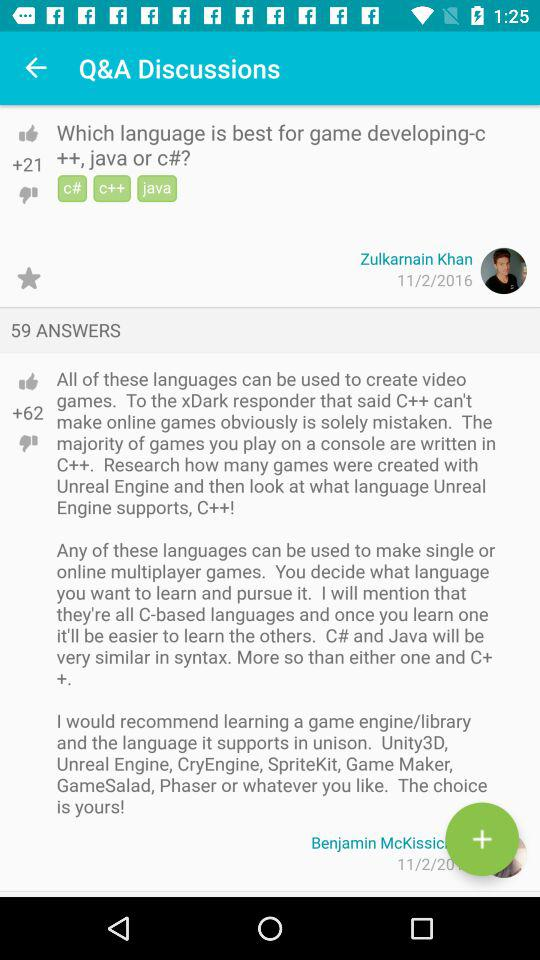On what date was the question by Zulkarnain Khan posted? The question by Zulkarnain Khan was posted on November 2, 2016. 